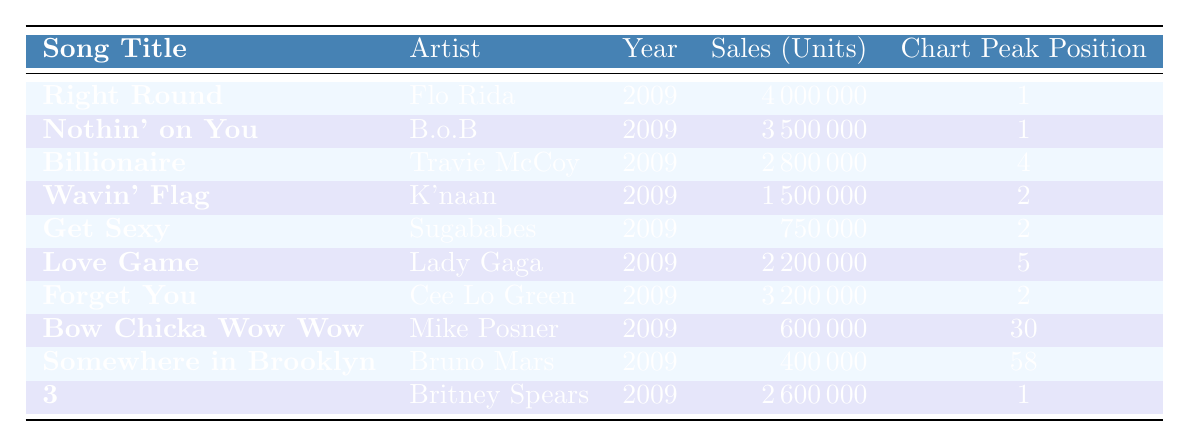What is the chart peak position of "Somewhere in Brooklyn"? The table shows that "Somewhere in Brooklyn" by Bruno Mars peaked at position 58 on the charts.
Answer: 58 Which song had the highest sales, and what were the sales figures? The song "Right Round" by Flo Rida had the highest sales, with 4,000,000 units sold.
Answer: 4,000,000 How many songs listed in the table reached a chart peak position of 1? There are 3 songs in the table that reached a chart peak position of 1: "Right Round," "Nothin' on You," and "3."
Answer: 3 What is the average sales figure of the songs listed in the table? To find the average sales, sum up all the sales figures: 4,000,000 + 3,500,000 + 2,800,000 + 1,500,000 + 750,000 + 2,200,000 + 3,200,000 + 600,000 + 400,000 + 2,600,000 = 21,600,000. There are 10 songs, so average sales = 21,600,000 / 10 = 2,160,000.
Answer: 2,160,000 Is "Bow Chicka Wow Wow" by Mike Posner more successful than "Somewhere in Brooklyn"? To determine this, we compare their sales figures: "Bow Chicka Wow Wow" sold 600,000 units, while "Somewhere in Brooklyn" sold 400,000 units, indicating that "Bow Chicka Wow Wow" is more successful.
Answer: Yes Which artist had the second highest-selling song based on the data provided? The second highest-selling song is "Nothin' on You" by B.o.B, with sales of 3,500,000 units.
Answer: Nothin' on You (B.o.B) What is the total sales of songs by artists who had a chart peak position of 2? The songs that peaked at position 2 are "Wavin' Flag" (1,500,000), "Get Sexy" (750,000), and "Forget You" (3,200,000). The total sales are 1,500,000 + 750,000 + 3,200,000 = 5,450,000.
Answer: 5,450,000 How many songs were released in 2009 according to the table? All the songs listed in the table are from the year 2009, totaling to 10 songs.
Answer: 10 Did any song produced by Bruno Mars sell more than 1 million units? "Somewhere in Brooklyn" sold 400,000 units, which is less than 1 million, so no songs produced by Bruno Mars sold more than 1 million units.
Answer: No What is the difference in sales between "Forget You" and "Love Game"? "Forget You" sold 3,200,000 units, and "Love Game" sold 2,200,000 units. The difference in sales is 3,200,000 - 2,200,000 = 1,000,000 units.
Answer: 1,000,000 Which artist had only one song listed in the table? Bruno Mars is the only artist listed with just one song titled "Somewhere in Brooklyn."
Answer: Bruno Mars 